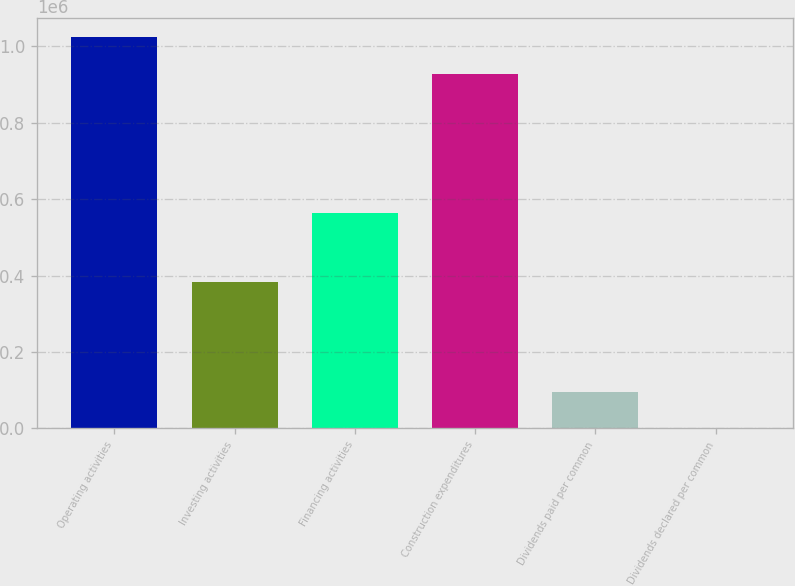Convert chart. <chart><loc_0><loc_0><loc_500><loc_500><bar_chart><fcel>Operating activities<fcel>Investing activities<fcel>Financing activities<fcel>Construction expenditures<fcel>Dividends paid per common<fcel>Dividends declared per common<nl><fcel>1.02413e+06<fcel>382356<fcel>563016<fcel>928574<fcel>95560.7<fcel>0.98<nl></chart> 